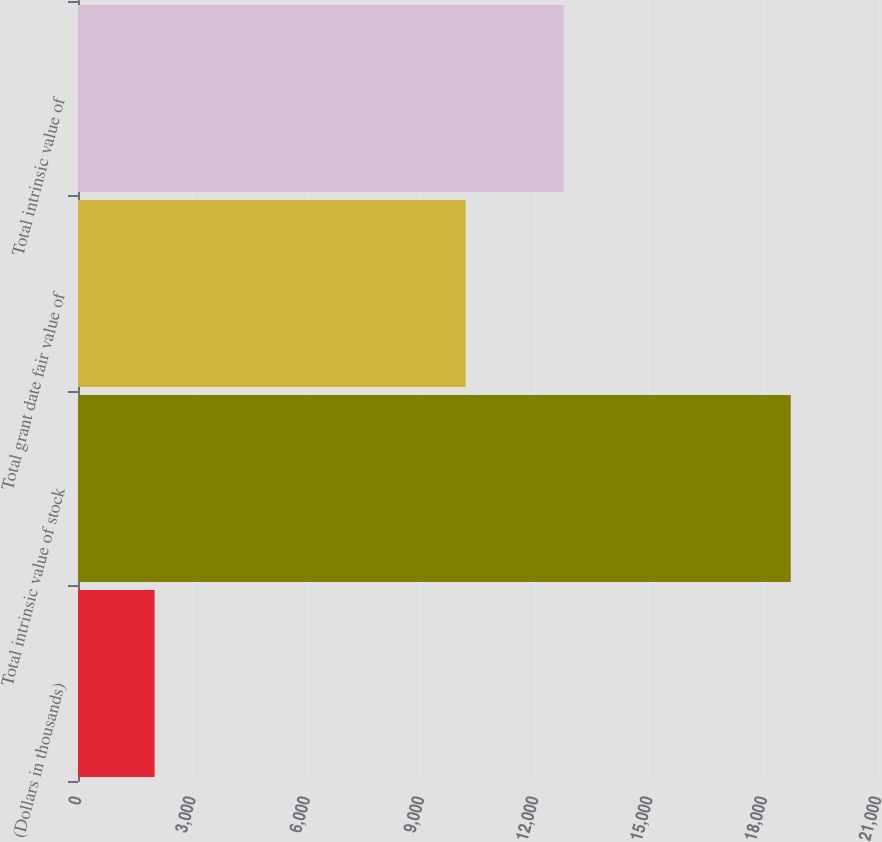Convert chart. <chart><loc_0><loc_0><loc_500><loc_500><bar_chart><fcel>(Dollars in thousands)<fcel>Total intrinsic value of stock<fcel>Total grant date fair value of<fcel>Total intrinsic value of<nl><fcel>2012<fcel>18709.7<fcel>10176<fcel>12747<nl></chart> 